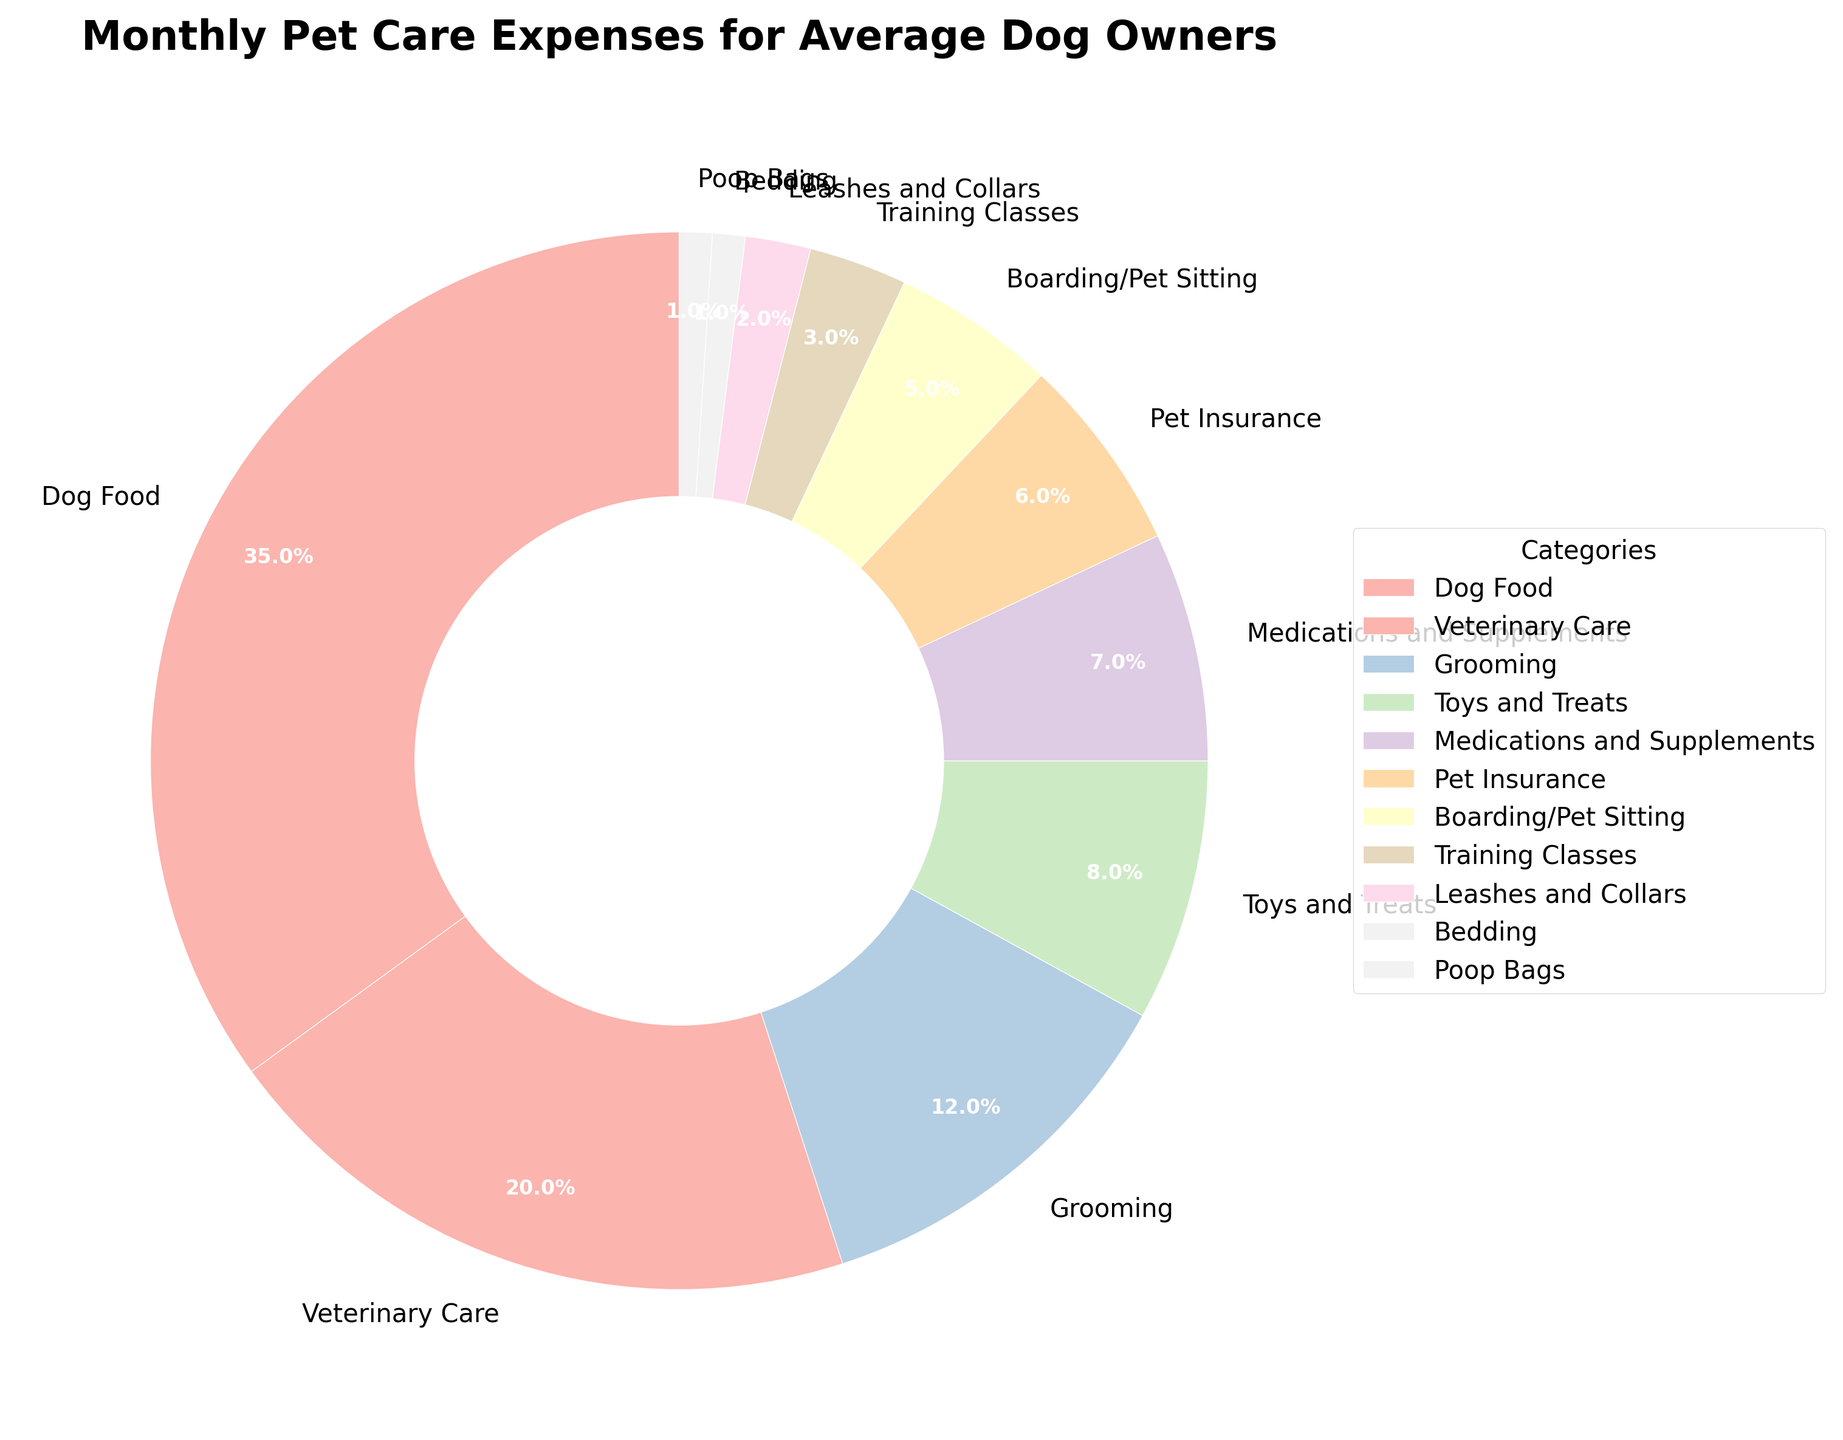Which category accounts for the highest percentage of monthly pet care expenses? The category "Dog Food" is represented by the largest section of the pie chart, indicating it has the highest percentage.
Answer: Dog Food What is the combined percentage of expenses for Veterinary Care and Grooming? The percentages for Veterinary Care and Grooming are 20% and 12% respectively. Adding them together, we get 20 + 12 = 32%.
Answer: 32% How much more do average dog owners spend on Dog Food compared to Pet Insurance? Dog Food accounts for 35% and Pet Insurance accounts for 6%. Subtracting the two, we get 35 - 6 = 29%.
Answer: 29% Which two categories together amount to the same percentage as Dog Food? Dog Food is 35%. Veterinary Care is 20% and Grooming is 12%, adding them together, 20 + 12 = 32%, which is less than 35%. Adding another small category, Toys and Treats which is 8%, 32 + 8 = 40%. Therefore, Veterinary Care (20%) and Grooming (12%) together with Medications and Supplements (7%) total (20 + 12 + 7 = 39%) close to Dog Food.
Answer: Veterinary Care, Grooming, Medications and Supplements or Veterinary Care, Grooming, Toys and Treats Which category has the smallest share of monthly pet expenses? The smallest sections in the pie chart are shared by "Bedding" and "Poop Bags," each accounting for 1%.
Answer: Bedding and Poop Bags Is the expenditure on Toys and Treats higher or lower than Medications and Supplements? The pie chart shows that Toys and Treats account for 8% while Medications and Supplements account for 7%. Thus, the expenditure on Toys and Treats is higher.
Answer: Higher By looking at the visual pattern, which color represents the Veterinary Care category? Veterinary Care is the second largest section and is colored as the second wedge in light pastel colors. Please refer to its specific color in the chart visually.
Answer: (user to refer specific color in chart) How do Boarding/Pet Sitting expenses compare to Training Classes? From the pie chart, Boarding/Pet Sitting expenses are 5% and Training Classes are 3%. Therefore, Boarding/Pet Sitting expenses are greater than Training Classes.
Answer: Greater What is the total percentage for all categories that constitute less than 10% each? Adding the percentages for Grooming (12%), Toys and Treats (8%), Medications and Supplements (7%), Pet Insurance (6%), Boarding/Pet Sitting (5%), Training Classes (3%), Leashes and Collars (2%), Bedding (1%), and Poop Bags (1%) gives us: 12 + 8 + 7 + 6 + 5 + 3 + 2 + 1 + 1 = 45%.
Answer: 45% 